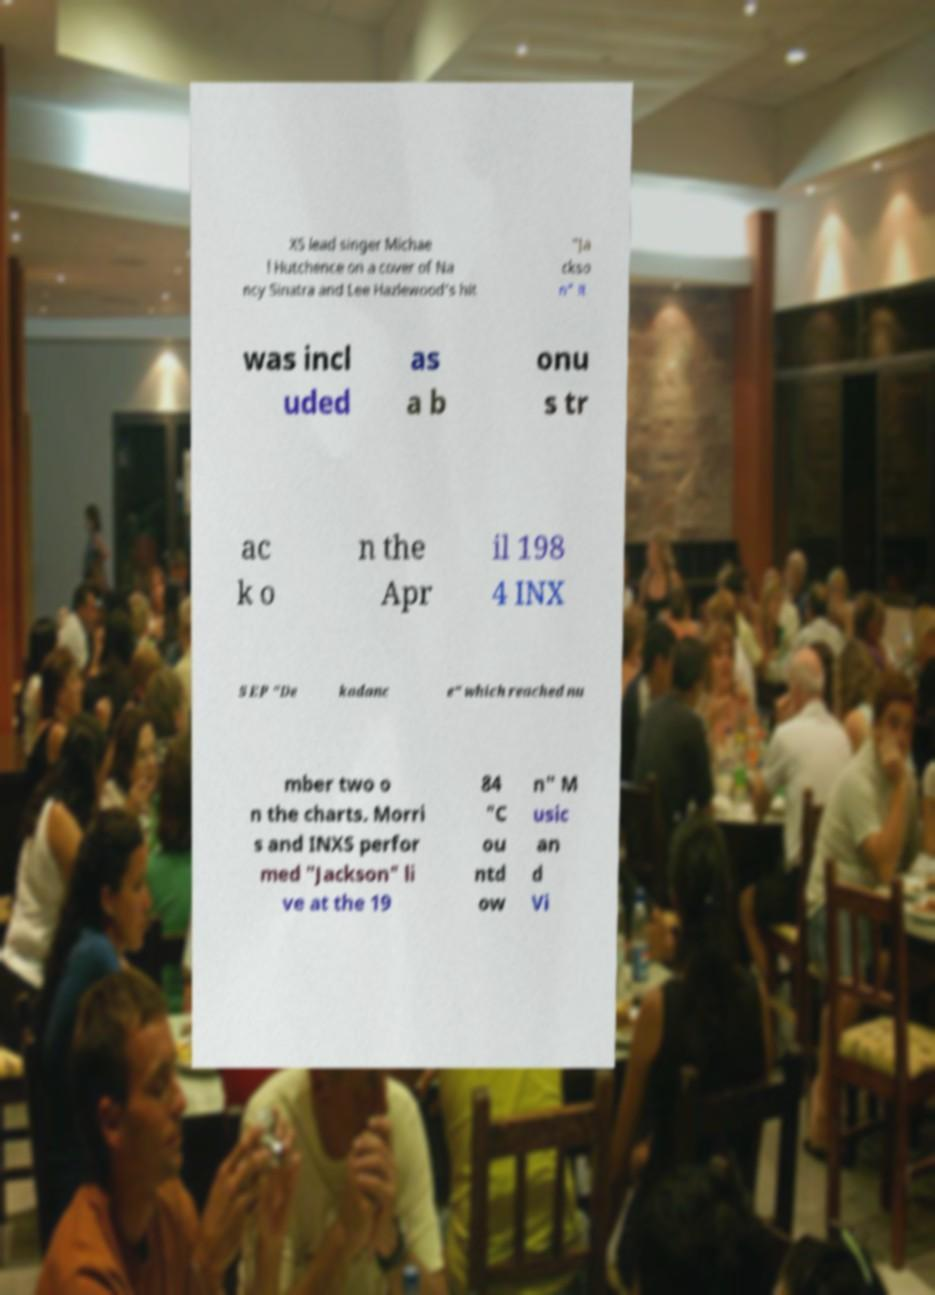Could you extract and type out the text from this image? XS lead singer Michae l Hutchence on a cover of Na ncy Sinatra and Lee Hazlewood's hit "Ja ckso n" it was incl uded as a b onu s tr ac k o n the Apr il 198 4 INX S EP "De kadanc e" which reached nu mber two o n the charts. Morri s and INXS perfor med "Jackson" li ve at the 19 84 "C ou ntd ow n" M usic an d Vi 